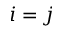<formula> <loc_0><loc_0><loc_500><loc_500>i = j</formula> 